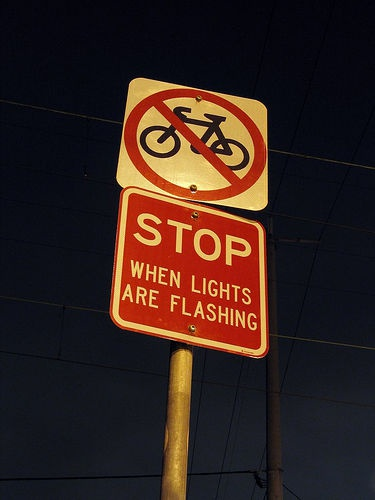Describe the objects in this image and their specific colors. I can see stop sign in black, brown, tan, and khaki tones and bicycle in black, tan, and brown tones in this image. 